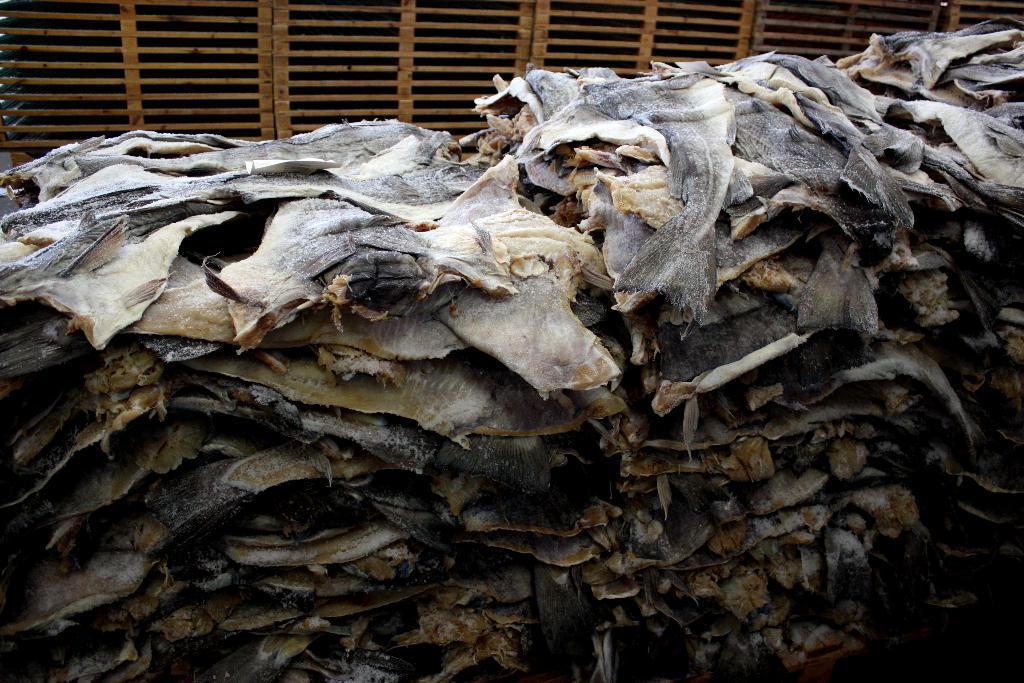Please provide a concise description of this image. In this picture there are few skins of fishes and there are some other objects beside it. 